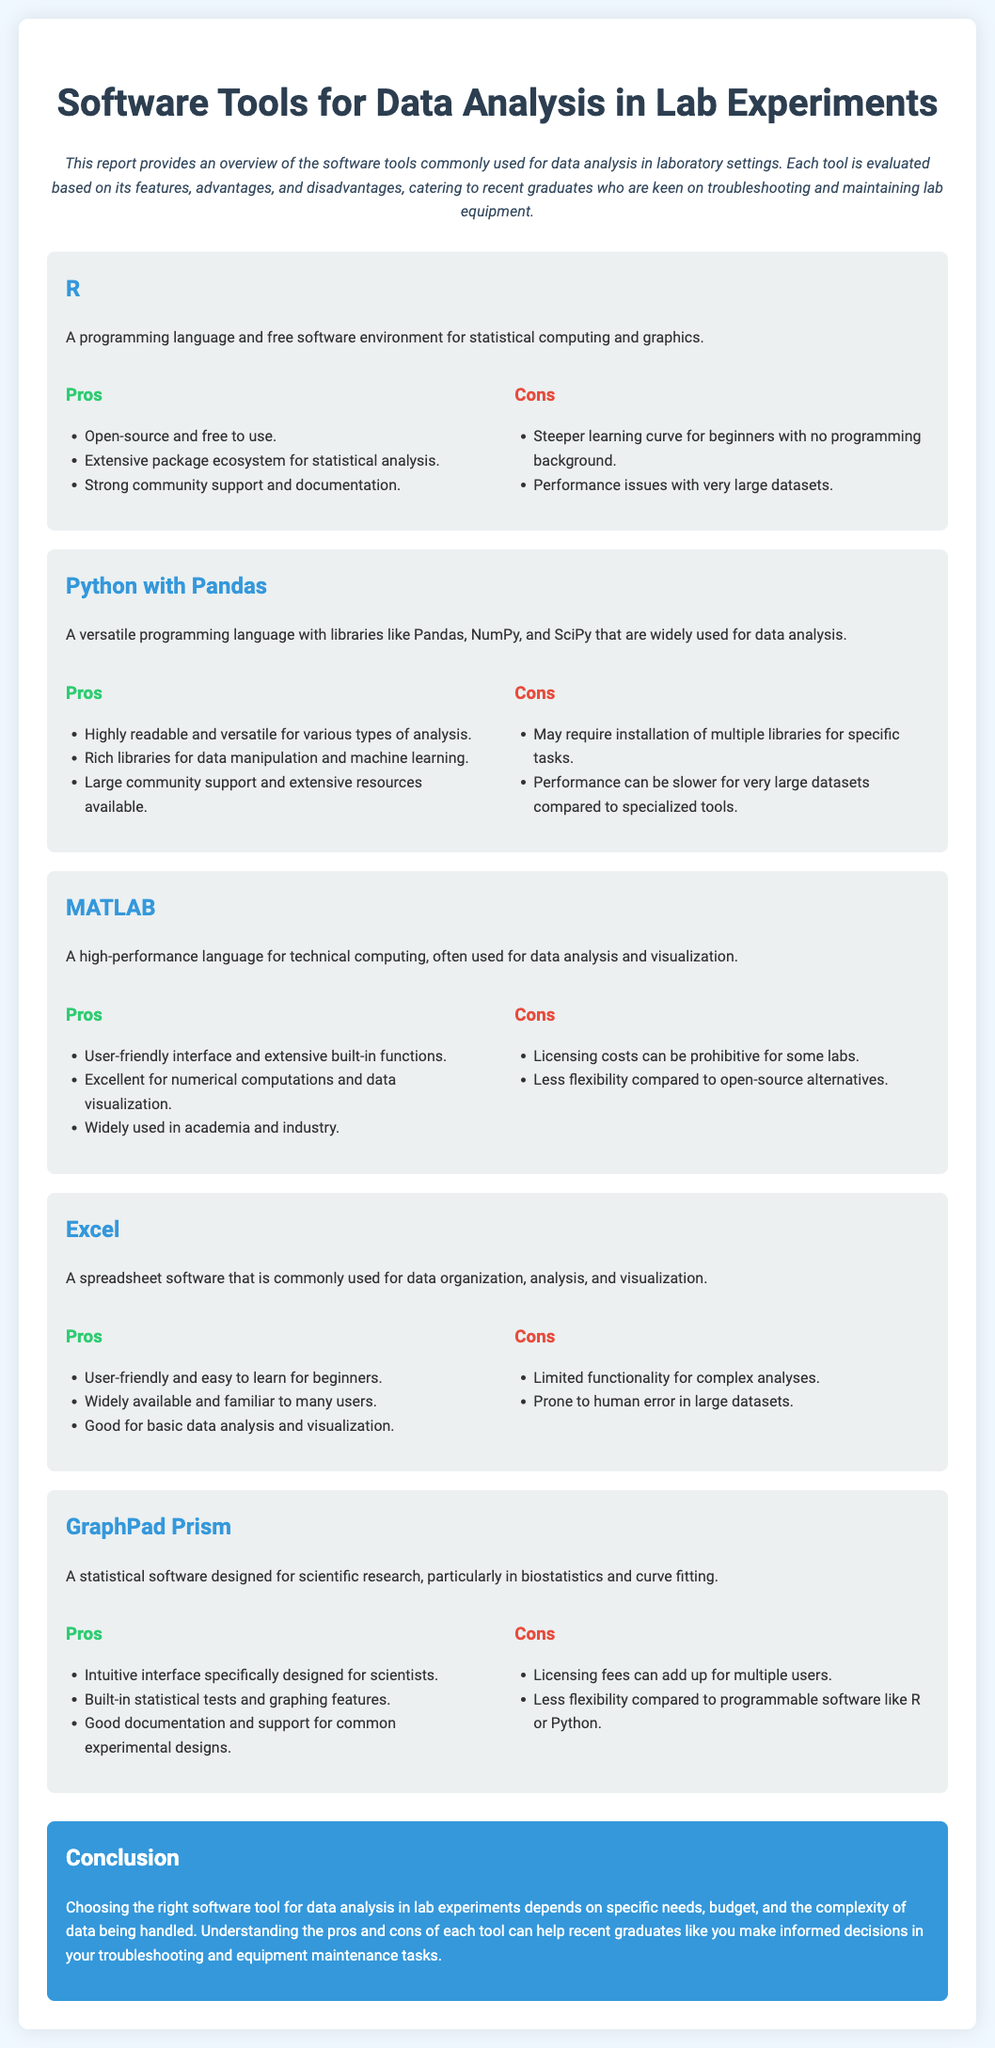What is the title of the report? The title is prominently displayed at the top of the document, summarizing its focus on software tools.
Answer: Software Tools for Data Analysis in Lab Experiments What is the programming language discussed that is known for its statistical computing? The document introduces a specific programming language specifically recognized for statistical analysis and graphics.
Answer: R What are the pros of using Python with Pandas? The pros section outlines advantages of Python with Pandas, focusing on its readability and versatility.
Answer: Highly readable and versatile for various types of analysis What is a key disadvantage of using Excel for data analysis? The cons section for Excel mentions a significant limitation affecting its effectiveness for complex tasks.
Answer: Limited functionality for complex analyses How many tools are evaluated in the report? The document clearly lists and describes multiple software tools used for data analysis, and we can count them.
Answer: Five What is a con of using GraphPad Prism? The cons section addresses specific drawbacks of GraphPad Prism related to licensing costs and flexibility.
Answer: Licensing fees can add up for multiple users Which tool is specifically mentioned as excellent for numerical computations? The description highlights MATLAB's strong capabilities in numerical operations.
Answer: MATLAB What conclusion does the report make regarding software tool selection? The conclusion summarizes the guiding factors for choosing the right software tools for data analysis.
Answer: Depends on specific needs, budget, and complexity of data 